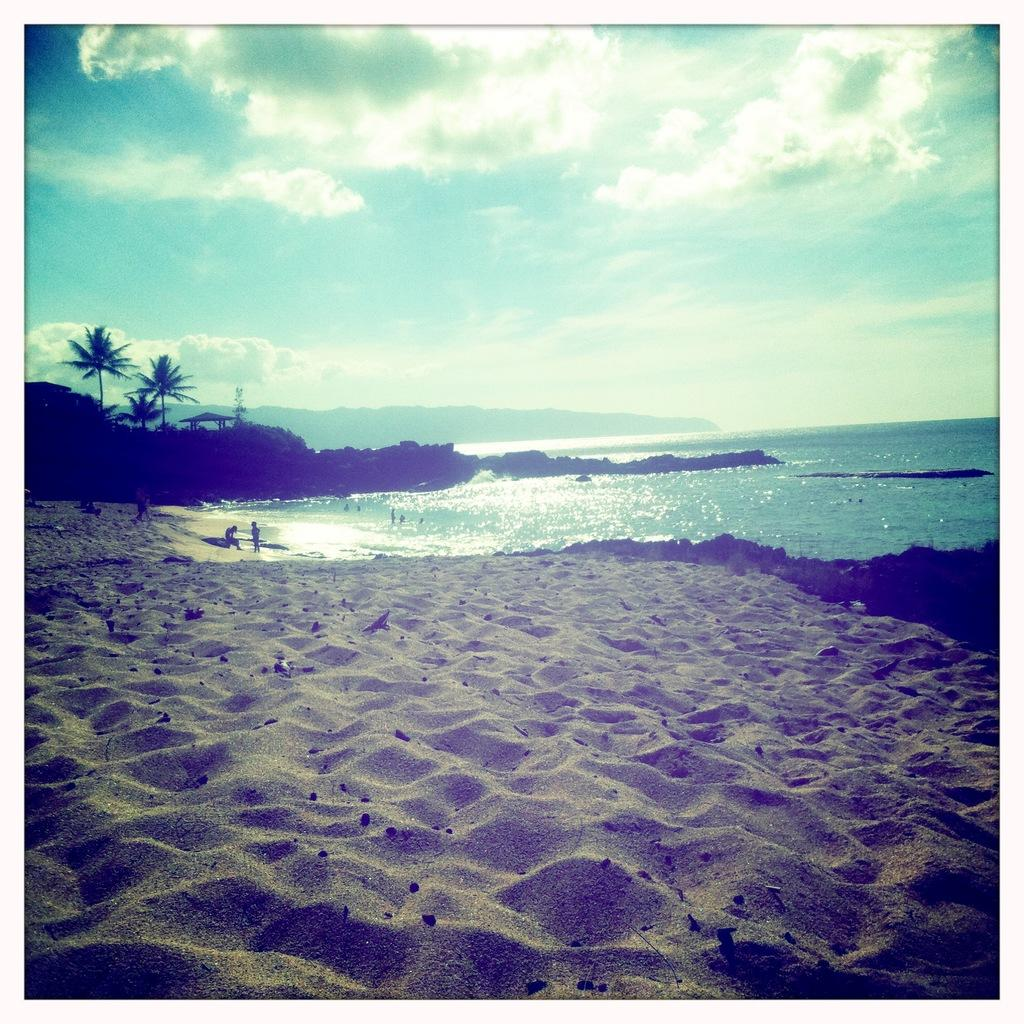What type of terrain is visible in the image? There is sand in the image. Can you describe the people in the image? There are people in the image. What natural element is visible in the image? There is water visible in the image. What can be seen in the background of the image? There are trees, a shed, hills, and the sky visible in the background of the image. What is the condition of the sky in the image? Clouds are present in the sky. How many nets are being used by the people in the image? There are no nets visible in the image. What type of bears can be seen interacting with the trees in the image? There are no bears present in the image; it features people, sand, water, and various background elements. 